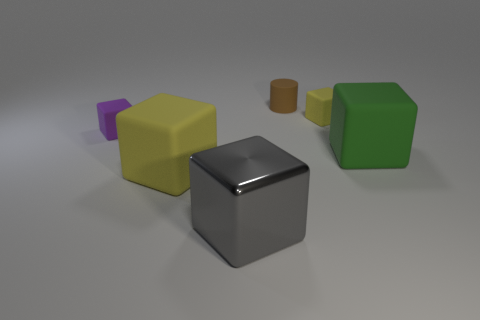Is there anything else that is made of the same material as the large gray block?
Your answer should be very brief. No. How big is the yellow matte object that is behind the green thing?
Provide a short and direct response. Small. What is the small purple object that is to the left of the big matte block to the left of the green matte object made of?
Make the answer very short. Rubber. How many tiny objects are in front of the tiny cube on the right side of the large rubber cube that is on the left side of the brown cylinder?
Your answer should be compact. 1. Is the material of the yellow cube that is in front of the green matte thing the same as the cube behind the purple rubber cube?
Ensure brevity in your answer.  Yes. How many big green matte things have the same shape as the tiny brown matte object?
Keep it short and to the point. 0. Is the number of small cubes right of the big gray object greater than the number of large blue cubes?
Provide a short and direct response. Yes. What is the shape of the tiny rubber object that is behind the yellow object to the right of the big rubber block that is to the left of the gray object?
Make the answer very short. Cylinder. Is the shape of the yellow thing that is to the right of the small brown matte thing the same as the brown object on the right side of the large yellow matte cube?
Your answer should be compact. No. What number of spheres are gray objects or tiny purple matte objects?
Make the answer very short. 0. 